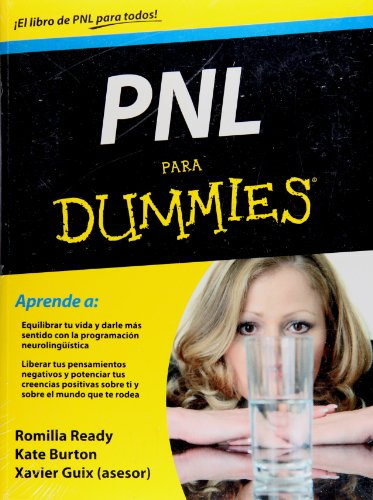How might this book be useful for someone with no prior knowledge of NLP? For a newcomer, this book serves as a primer on the basics of NLP. It likely breaks down complex concepts into digestible segments, explaining them with clear examples and offering practical exercises to apply NLP techniques in everyday life, making it a great starting point for personal development. 